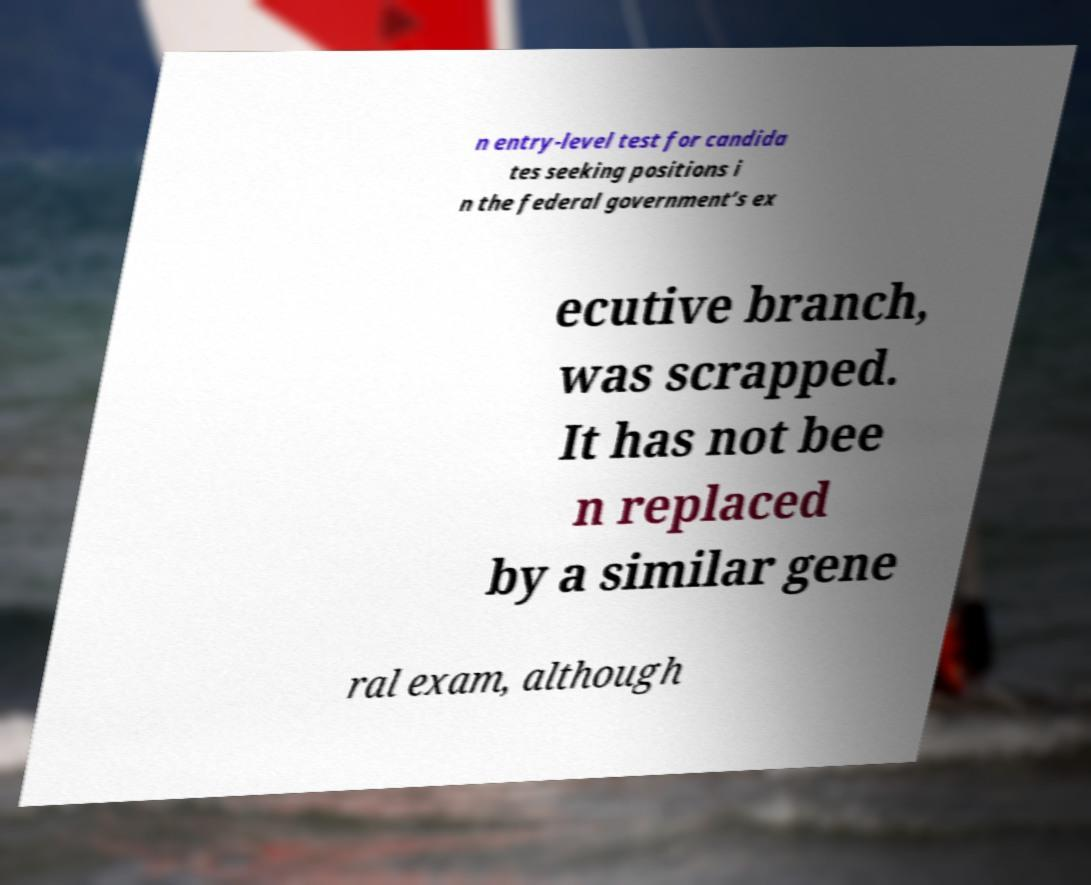I need the written content from this picture converted into text. Can you do that? n entry-level test for candida tes seeking positions i n the federal government’s ex ecutive branch, was scrapped. It has not bee n replaced by a similar gene ral exam, although 